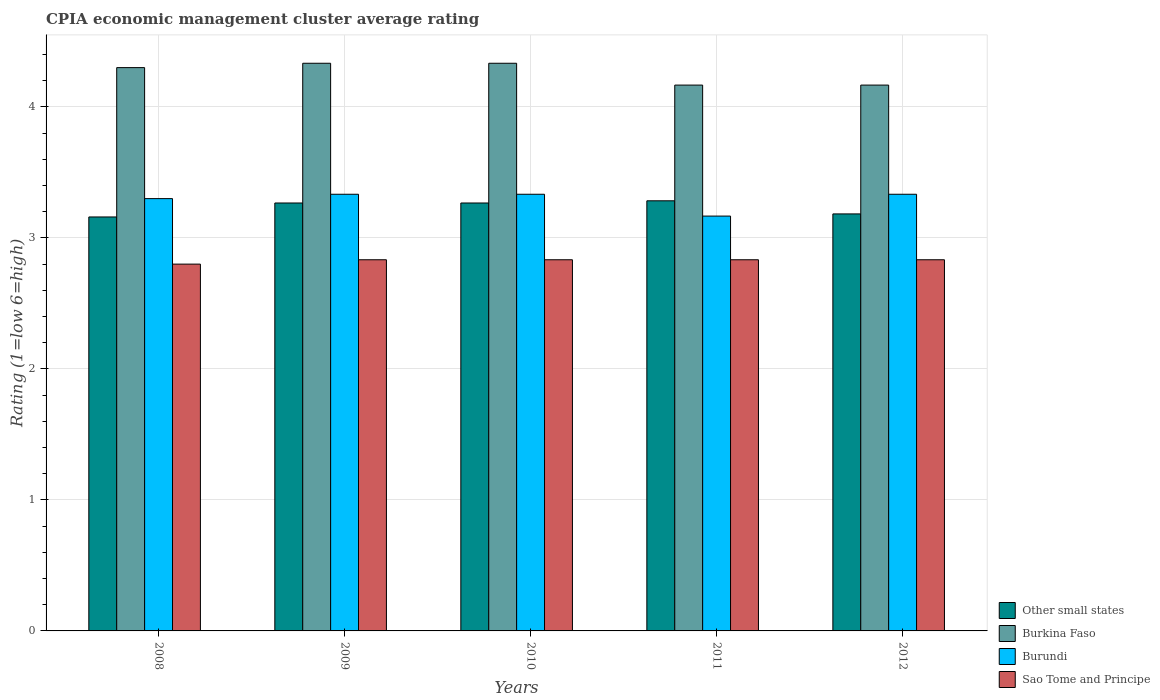Are the number of bars per tick equal to the number of legend labels?
Your response must be concise. Yes. What is the CPIA rating in Other small states in 2010?
Provide a short and direct response. 3.27. Across all years, what is the maximum CPIA rating in Burkina Faso?
Provide a short and direct response. 4.33. Across all years, what is the minimum CPIA rating in Sao Tome and Principe?
Your answer should be compact. 2.8. In which year was the CPIA rating in Burkina Faso minimum?
Provide a succinct answer. 2011. What is the total CPIA rating in Other small states in the graph?
Ensure brevity in your answer.  16.16. What is the difference between the CPIA rating in Other small states in 2010 and that in 2011?
Provide a succinct answer. -0.02. What is the difference between the CPIA rating in Sao Tome and Principe in 2011 and the CPIA rating in Burkina Faso in 2008?
Offer a terse response. -1.47. What is the average CPIA rating in Sao Tome and Principe per year?
Keep it short and to the point. 2.83. What is the ratio of the CPIA rating in Other small states in 2011 to that in 2012?
Offer a terse response. 1.03. What is the difference between the highest and the second highest CPIA rating in Burkina Faso?
Provide a succinct answer. 0. What is the difference between the highest and the lowest CPIA rating in Other small states?
Your answer should be compact. 0.12. In how many years, is the CPIA rating in Sao Tome and Principe greater than the average CPIA rating in Sao Tome and Principe taken over all years?
Give a very brief answer. 4. Is the sum of the CPIA rating in Burundi in 2008 and 2012 greater than the maximum CPIA rating in Burkina Faso across all years?
Your response must be concise. Yes. Is it the case that in every year, the sum of the CPIA rating in Burkina Faso and CPIA rating in Sao Tome and Principe is greater than the sum of CPIA rating in Burundi and CPIA rating in Other small states?
Provide a succinct answer. Yes. What does the 1st bar from the left in 2008 represents?
Ensure brevity in your answer.  Other small states. What does the 4th bar from the right in 2010 represents?
Keep it short and to the point. Other small states. Are all the bars in the graph horizontal?
Offer a terse response. No. How many years are there in the graph?
Provide a succinct answer. 5. Does the graph contain any zero values?
Your answer should be very brief. No. Does the graph contain grids?
Offer a very short reply. Yes. Where does the legend appear in the graph?
Your answer should be very brief. Bottom right. How many legend labels are there?
Offer a terse response. 4. What is the title of the graph?
Make the answer very short. CPIA economic management cluster average rating. What is the label or title of the Y-axis?
Provide a short and direct response. Rating (1=low 6=high). What is the Rating (1=low 6=high) in Other small states in 2008?
Offer a very short reply. 3.16. What is the Rating (1=low 6=high) of Burundi in 2008?
Your answer should be very brief. 3.3. What is the Rating (1=low 6=high) of Sao Tome and Principe in 2008?
Offer a very short reply. 2.8. What is the Rating (1=low 6=high) in Other small states in 2009?
Your answer should be compact. 3.27. What is the Rating (1=low 6=high) of Burkina Faso in 2009?
Ensure brevity in your answer.  4.33. What is the Rating (1=low 6=high) of Burundi in 2009?
Provide a succinct answer. 3.33. What is the Rating (1=low 6=high) in Sao Tome and Principe in 2009?
Offer a terse response. 2.83. What is the Rating (1=low 6=high) in Other small states in 2010?
Keep it short and to the point. 3.27. What is the Rating (1=low 6=high) in Burkina Faso in 2010?
Provide a succinct answer. 4.33. What is the Rating (1=low 6=high) of Burundi in 2010?
Provide a short and direct response. 3.33. What is the Rating (1=low 6=high) in Sao Tome and Principe in 2010?
Make the answer very short. 2.83. What is the Rating (1=low 6=high) in Other small states in 2011?
Your answer should be very brief. 3.28. What is the Rating (1=low 6=high) in Burkina Faso in 2011?
Provide a short and direct response. 4.17. What is the Rating (1=low 6=high) of Burundi in 2011?
Provide a succinct answer. 3.17. What is the Rating (1=low 6=high) of Sao Tome and Principe in 2011?
Your answer should be compact. 2.83. What is the Rating (1=low 6=high) of Other small states in 2012?
Provide a succinct answer. 3.18. What is the Rating (1=low 6=high) in Burkina Faso in 2012?
Provide a succinct answer. 4.17. What is the Rating (1=low 6=high) in Burundi in 2012?
Offer a terse response. 3.33. What is the Rating (1=low 6=high) of Sao Tome and Principe in 2012?
Your answer should be compact. 2.83. Across all years, what is the maximum Rating (1=low 6=high) in Other small states?
Offer a very short reply. 3.28. Across all years, what is the maximum Rating (1=low 6=high) in Burkina Faso?
Offer a very short reply. 4.33. Across all years, what is the maximum Rating (1=low 6=high) in Burundi?
Provide a short and direct response. 3.33. Across all years, what is the maximum Rating (1=low 6=high) in Sao Tome and Principe?
Your answer should be compact. 2.83. Across all years, what is the minimum Rating (1=low 6=high) of Other small states?
Your response must be concise. 3.16. Across all years, what is the minimum Rating (1=low 6=high) in Burkina Faso?
Make the answer very short. 4.17. Across all years, what is the minimum Rating (1=low 6=high) in Burundi?
Offer a very short reply. 3.17. Across all years, what is the minimum Rating (1=low 6=high) of Sao Tome and Principe?
Provide a succinct answer. 2.8. What is the total Rating (1=low 6=high) of Other small states in the graph?
Your answer should be compact. 16.16. What is the total Rating (1=low 6=high) of Burkina Faso in the graph?
Provide a short and direct response. 21.3. What is the total Rating (1=low 6=high) of Burundi in the graph?
Provide a succinct answer. 16.47. What is the total Rating (1=low 6=high) of Sao Tome and Principe in the graph?
Offer a very short reply. 14.13. What is the difference between the Rating (1=low 6=high) in Other small states in 2008 and that in 2009?
Offer a terse response. -0.11. What is the difference between the Rating (1=low 6=high) in Burkina Faso in 2008 and that in 2009?
Provide a short and direct response. -0.03. What is the difference between the Rating (1=low 6=high) of Burundi in 2008 and that in 2009?
Offer a terse response. -0.03. What is the difference between the Rating (1=low 6=high) of Sao Tome and Principe in 2008 and that in 2009?
Your answer should be compact. -0.03. What is the difference between the Rating (1=low 6=high) in Other small states in 2008 and that in 2010?
Provide a succinct answer. -0.11. What is the difference between the Rating (1=low 6=high) in Burkina Faso in 2008 and that in 2010?
Ensure brevity in your answer.  -0.03. What is the difference between the Rating (1=low 6=high) in Burundi in 2008 and that in 2010?
Your answer should be compact. -0.03. What is the difference between the Rating (1=low 6=high) of Sao Tome and Principe in 2008 and that in 2010?
Your answer should be compact. -0.03. What is the difference between the Rating (1=low 6=high) of Other small states in 2008 and that in 2011?
Provide a succinct answer. -0.12. What is the difference between the Rating (1=low 6=high) of Burkina Faso in 2008 and that in 2011?
Provide a short and direct response. 0.13. What is the difference between the Rating (1=low 6=high) in Burundi in 2008 and that in 2011?
Your answer should be very brief. 0.13. What is the difference between the Rating (1=low 6=high) of Sao Tome and Principe in 2008 and that in 2011?
Provide a succinct answer. -0.03. What is the difference between the Rating (1=low 6=high) in Other small states in 2008 and that in 2012?
Your answer should be very brief. -0.02. What is the difference between the Rating (1=low 6=high) in Burkina Faso in 2008 and that in 2012?
Your answer should be compact. 0.13. What is the difference between the Rating (1=low 6=high) of Burundi in 2008 and that in 2012?
Give a very brief answer. -0.03. What is the difference between the Rating (1=low 6=high) in Sao Tome and Principe in 2008 and that in 2012?
Give a very brief answer. -0.03. What is the difference between the Rating (1=low 6=high) in Burundi in 2009 and that in 2010?
Offer a very short reply. 0. What is the difference between the Rating (1=low 6=high) in Other small states in 2009 and that in 2011?
Your response must be concise. -0.02. What is the difference between the Rating (1=low 6=high) in Burkina Faso in 2009 and that in 2011?
Your answer should be very brief. 0.17. What is the difference between the Rating (1=low 6=high) in Sao Tome and Principe in 2009 and that in 2011?
Keep it short and to the point. 0. What is the difference between the Rating (1=low 6=high) in Other small states in 2009 and that in 2012?
Ensure brevity in your answer.  0.08. What is the difference between the Rating (1=low 6=high) in Burkina Faso in 2009 and that in 2012?
Offer a very short reply. 0.17. What is the difference between the Rating (1=low 6=high) of Burundi in 2009 and that in 2012?
Give a very brief answer. 0. What is the difference between the Rating (1=low 6=high) in Sao Tome and Principe in 2009 and that in 2012?
Provide a succinct answer. 0. What is the difference between the Rating (1=low 6=high) of Other small states in 2010 and that in 2011?
Your answer should be very brief. -0.02. What is the difference between the Rating (1=low 6=high) of Burkina Faso in 2010 and that in 2011?
Keep it short and to the point. 0.17. What is the difference between the Rating (1=low 6=high) in Sao Tome and Principe in 2010 and that in 2011?
Offer a very short reply. 0. What is the difference between the Rating (1=low 6=high) of Other small states in 2010 and that in 2012?
Make the answer very short. 0.08. What is the difference between the Rating (1=low 6=high) in Burkina Faso in 2010 and that in 2012?
Provide a succinct answer. 0.17. What is the difference between the Rating (1=low 6=high) in Sao Tome and Principe in 2010 and that in 2012?
Offer a terse response. 0. What is the difference between the Rating (1=low 6=high) in Burundi in 2011 and that in 2012?
Ensure brevity in your answer.  -0.17. What is the difference between the Rating (1=low 6=high) of Other small states in 2008 and the Rating (1=low 6=high) of Burkina Faso in 2009?
Offer a terse response. -1.17. What is the difference between the Rating (1=low 6=high) in Other small states in 2008 and the Rating (1=low 6=high) in Burundi in 2009?
Make the answer very short. -0.17. What is the difference between the Rating (1=low 6=high) of Other small states in 2008 and the Rating (1=low 6=high) of Sao Tome and Principe in 2009?
Offer a very short reply. 0.33. What is the difference between the Rating (1=low 6=high) of Burkina Faso in 2008 and the Rating (1=low 6=high) of Burundi in 2009?
Your response must be concise. 0.97. What is the difference between the Rating (1=low 6=high) of Burkina Faso in 2008 and the Rating (1=low 6=high) of Sao Tome and Principe in 2009?
Keep it short and to the point. 1.47. What is the difference between the Rating (1=low 6=high) of Burundi in 2008 and the Rating (1=low 6=high) of Sao Tome and Principe in 2009?
Provide a succinct answer. 0.47. What is the difference between the Rating (1=low 6=high) in Other small states in 2008 and the Rating (1=low 6=high) in Burkina Faso in 2010?
Provide a short and direct response. -1.17. What is the difference between the Rating (1=low 6=high) in Other small states in 2008 and the Rating (1=low 6=high) in Burundi in 2010?
Provide a short and direct response. -0.17. What is the difference between the Rating (1=low 6=high) of Other small states in 2008 and the Rating (1=low 6=high) of Sao Tome and Principe in 2010?
Provide a succinct answer. 0.33. What is the difference between the Rating (1=low 6=high) of Burkina Faso in 2008 and the Rating (1=low 6=high) of Burundi in 2010?
Make the answer very short. 0.97. What is the difference between the Rating (1=low 6=high) of Burkina Faso in 2008 and the Rating (1=low 6=high) of Sao Tome and Principe in 2010?
Offer a very short reply. 1.47. What is the difference between the Rating (1=low 6=high) of Burundi in 2008 and the Rating (1=low 6=high) of Sao Tome and Principe in 2010?
Make the answer very short. 0.47. What is the difference between the Rating (1=low 6=high) in Other small states in 2008 and the Rating (1=low 6=high) in Burkina Faso in 2011?
Your answer should be compact. -1.01. What is the difference between the Rating (1=low 6=high) of Other small states in 2008 and the Rating (1=low 6=high) of Burundi in 2011?
Your response must be concise. -0.01. What is the difference between the Rating (1=low 6=high) of Other small states in 2008 and the Rating (1=low 6=high) of Sao Tome and Principe in 2011?
Give a very brief answer. 0.33. What is the difference between the Rating (1=low 6=high) of Burkina Faso in 2008 and the Rating (1=low 6=high) of Burundi in 2011?
Make the answer very short. 1.13. What is the difference between the Rating (1=low 6=high) in Burkina Faso in 2008 and the Rating (1=low 6=high) in Sao Tome and Principe in 2011?
Make the answer very short. 1.47. What is the difference between the Rating (1=low 6=high) in Burundi in 2008 and the Rating (1=low 6=high) in Sao Tome and Principe in 2011?
Provide a short and direct response. 0.47. What is the difference between the Rating (1=low 6=high) of Other small states in 2008 and the Rating (1=low 6=high) of Burkina Faso in 2012?
Your answer should be very brief. -1.01. What is the difference between the Rating (1=low 6=high) in Other small states in 2008 and the Rating (1=low 6=high) in Burundi in 2012?
Make the answer very short. -0.17. What is the difference between the Rating (1=low 6=high) of Other small states in 2008 and the Rating (1=low 6=high) of Sao Tome and Principe in 2012?
Provide a succinct answer. 0.33. What is the difference between the Rating (1=low 6=high) of Burkina Faso in 2008 and the Rating (1=low 6=high) of Burundi in 2012?
Offer a terse response. 0.97. What is the difference between the Rating (1=low 6=high) in Burkina Faso in 2008 and the Rating (1=low 6=high) in Sao Tome and Principe in 2012?
Ensure brevity in your answer.  1.47. What is the difference between the Rating (1=low 6=high) in Burundi in 2008 and the Rating (1=low 6=high) in Sao Tome and Principe in 2012?
Provide a succinct answer. 0.47. What is the difference between the Rating (1=low 6=high) in Other small states in 2009 and the Rating (1=low 6=high) in Burkina Faso in 2010?
Your answer should be very brief. -1.07. What is the difference between the Rating (1=low 6=high) in Other small states in 2009 and the Rating (1=low 6=high) in Burundi in 2010?
Make the answer very short. -0.07. What is the difference between the Rating (1=low 6=high) in Other small states in 2009 and the Rating (1=low 6=high) in Sao Tome and Principe in 2010?
Provide a short and direct response. 0.43. What is the difference between the Rating (1=low 6=high) of Burkina Faso in 2009 and the Rating (1=low 6=high) of Sao Tome and Principe in 2010?
Provide a short and direct response. 1.5. What is the difference between the Rating (1=low 6=high) in Burundi in 2009 and the Rating (1=low 6=high) in Sao Tome and Principe in 2010?
Provide a short and direct response. 0.5. What is the difference between the Rating (1=low 6=high) in Other small states in 2009 and the Rating (1=low 6=high) in Burkina Faso in 2011?
Offer a terse response. -0.9. What is the difference between the Rating (1=low 6=high) in Other small states in 2009 and the Rating (1=low 6=high) in Sao Tome and Principe in 2011?
Give a very brief answer. 0.43. What is the difference between the Rating (1=low 6=high) of Burkina Faso in 2009 and the Rating (1=low 6=high) of Burundi in 2011?
Offer a terse response. 1.17. What is the difference between the Rating (1=low 6=high) in Burkina Faso in 2009 and the Rating (1=low 6=high) in Sao Tome and Principe in 2011?
Keep it short and to the point. 1.5. What is the difference between the Rating (1=low 6=high) of Other small states in 2009 and the Rating (1=low 6=high) of Burkina Faso in 2012?
Offer a very short reply. -0.9. What is the difference between the Rating (1=low 6=high) of Other small states in 2009 and the Rating (1=low 6=high) of Burundi in 2012?
Give a very brief answer. -0.07. What is the difference between the Rating (1=low 6=high) of Other small states in 2009 and the Rating (1=low 6=high) of Sao Tome and Principe in 2012?
Offer a terse response. 0.43. What is the difference between the Rating (1=low 6=high) of Burkina Faso in 2009 and the Rating (1=low 6=high) of Burundi in 2012?
Ensure brevity in your answer.  1. What is the difference between the Rating (1=low 6=high) in Burkina Faso in 2009 and the Rating (1=low 6=high) in Sao Tome and Principe in 2012?
Your answer should be very brief. 1.5. What is the difference between the Rating (1=low 6=high) of Burundi in 2009 and the Rating (1=low 6=high) of Sao Tome and Principe in 2012?
Your answer should be compact. 0.5. What is the difference between the Rating (1=low 6=high) of Other small states in 2010 and the Rating (1=low 6=high) of Burkina Faso in 2011?
Offer a very short reply. -0.9. What is the difference between the Rating (1=low 6=high) of Other small states in 2010 and the Rating (1=low 6=high) of Burundi in 2011?
Offer a terse response. 0.1. What is the difference between the Rating (1=low 6=high) of Other small states in 2010 and the Rating (1=low 6=high) of Sao Tome and Principe in 2011?
Ensure brevity in your answer.  0.43. What is the difference between the Rating (1=low 6=high) of Burkina Faso in 2010 and the Rating (1=low 6=high) of Sao Tome and Principe in 2011?
Your response must be concise. 1.5. What is the difference between the Rating (1=low 6=high) in Burundi in 2010 and the Rating (1=low 6=high) in Sao Tome and Principe in 2011?
Your answer should be very brief. 0.5. What is the difference between the Rating (1=low 6=high) in Other small states in 2010 and the Rating (1=low 6=high) in Burundi in 2012?
Offer a very short reply. -0.07. What is the difference between the Rating (1=low 6=high) in Other small states in 2010 and the Rating (1=low 6=high) in Sao Tome and Principe in 2012?
Give a very brief answer. 0.43. What is the difference between the Rating (1=low 6=high) of Burkina Faso in 2010 and the Rating (1=low 6=high) of Burundi in 2012?
Make the answer very short. 1. What is the difference between the Rating (1=low 6=high) in Burkina Faso in 2010 and the Rating (1=low 6=high) in Sao Tome and Principe in 2012?
Your answer should be very brief. 1.5. What is the difference between the Rating (1=low 6=high) in Burundi in 2010 and the Rating (1=low 6=high) in Sao Tome and Principe in 2012?
Provide a succinct answer. 0.5. What is the difference between the Rating (1=low 6=high) in Other small states in 2011 and the Rating (1=low 6=high) in Burkina Faso in 2012?
Give a very brief answer. -0.88. What is the difference between the Rating (1=low 6=high) of Other small states in 2011 and the Rating (1=low 6=high) of Sao Tome and Principe in 2012?
Provide a succinct answer. 0.45. What is the difference between the Rating (1=low 6=high) of Burkina Faso in 2011 and the Rating (1=low 6=high) of Sao Tome and Principe in 2012?
Provide a short and direct response. 1.33. What is the difference between the Rating (1=low 6=high) in Burundi in 2011 and the Rating (1=low 6=high) in Sao Tome and Principe in 2012?
Offer a very short reply. 0.33. What is the average Rating (1=low 6=high) in Other small states per year?
Make the answer very short. 3.23. What is the average Rating (1=low 6=high) of Burkina Faso per year?
Provide a short and direct response. 4.26. What is the average Rating (1=low 6=high) of Burundi per year?
Provide a succinct answer. 3.29. What is the average Rating (1=low 6=high) of Sao Tome and Principe per year?
Your answer should be compact. 2.83. In the year 2008, what is the difference between the Rating (1=low 6=high) of Other small states and Rating (1=low 6=high) of Burkina Faso?
Ensure brevity in your answer.  -1.14. In the year 2008, what is the difference between the Rating (1=low 6=high) in Other small states and Rating (1=low 6=high) in Burundi?
Ensure brevity in your answer.  -0.14. In the year 2008, what is the difference between the Rating (1=low 6=high) of Other small states and Rating (1=low 6=high) of Sao Tome and Principe?
Ensure brevity in your answer.  0.36. In the year 2009, what is the difference between the Rating (1=low 6=high) of Other small states and Rating (1=low 6=high) of Burkina Faso?
Offer a very short reply. -1.07. In the year 2009, what is the difference between the Rating (1=low 6=high) in Other small states and Rating (1=low 6=high) in Burundi?
Give a very brief answer. -0.07. In the year 2009, what is the difference between the Rating (1=low 6=high) of Other small states and Rating (1=low 6=high) of Sao Tome and Principe?
Offer a very short reply. 0.43. In the year 2009, what is the difference between the Rating (1=low 6=high) in Burkina Faso and Rating (1=low 6=high) in Burundi?
Offer a terse response. 1. In the year 2010, what is the difference between the Rating (1=low 6=high) of Other small states and Rating (1=low 6=high) of Burkina Faso?
Provide a short and direct response. -1.07. In the year 2010, what is the difference between the Rating (1=low 6=high) in Other small states and Rating (1=low 6=high) in Burundi?
Provide a short and direct response. -0.07. In the year 2010, what is the difference between the Rating (1=low 6=high) of Other small states and Rating (1=low 6=high) of Sao Tome and Principe?
Give a very brief answer. 0.43. In the year 2010, what is the difference between the Rating (1=low 6=high) of Burkina Faso and Rating (1=low 6=high) of Burundi?
Give a very brief answer. 1. In the year 2011, what is the difference between the Rating (1=low 6=high) in Other small states and Rating (1=low 6=high) in Burkina Faso?
Ensure brevity in your answer.  -0.88. In the year 2011, what is the difference between the Rating (1=low 6=high) of Other small states and Rating (1=low 6=high) of Burundi?
Offer a very short reply. 0.12. In the year 2011, what is the difference between the Rating (1=low 6=high) in Other small states and Rating (1=low 6=high) in Sao Tome and Principe?
Ensure brevity in your answer.  0.45. In the year 2011, what is the difference between the Rating (1=low 6=high) of Burkina Faso and Rating (1=low 6=high) of Sao Tome and Principe?
Your answer should be compact. 1.33. In the year 2012, what is the difference between the Rating (1=low 6=high) in Other small states and Rating (1=low 6=high) in Burkina Faso?
Your answer should be compact. -0.98. In the year 2012, what is the difference between the Rating (1=low 6=high) in Other small states and Rating (1=low 6=high) in Burundi?
Offer a terse response. -0.15. In the year 2012, what is the difference between the Rating (1=low 6=high) of Burkina Faso and Rating (1=low 6=high) of Sao Tome and Principe?
Your answer should be very brief. 1.33. In the year 2012, what is the difference between the Rating (1=low 6=high) of Burundi and Rating (1=low 6=high) of Sao Tome and Principe?
Ensure brevity in your answer.  0.5. What is the ratio of the Rating (1=low 6=high) in Other small states in 2008 to that in 2009?
Ensure brevity in your answer.  0.97. What is the ratio of the Rating (1=low 6=high) in Burundi in 2008 to that in 2009?
Your response must be concise. 0.99. What is the ratio of the Rating (1=low 6=high) in Sao Tome and Principe in 2008 to that in 2009?
Ensure brevity in your answer.  0.99. What is the ratio of the Rating (1=low 6=high) of Other small states in 2008 to that in 2010?
Your answer should be compact. 0.97. What is the ratio of the Rating (1=low 6=high) in Sao Tome and Principe in 2008 to that in 2010?
Offer a terse response. 0.99. What is the ratio of the Rating (1=low 6=high) of Other small states in 2008 to that in 2011?
Your response must be concise. 0.96. What is the ratio of the Rating (1=low 6=high) in Burkina Faso in 2008 to that in 2011?
Ensure brevity in your answer.  1.03. What is the ratio of the Rating (1=low 6=high) in Burundi in 2008 to that in 2011?
Give a very brief answer. 1.04. What is the ratio of the Rating (1=low 6=high) of Burkina Faso in 2008 to that in 2012?
Give a very brief answer. 1.03. What is the ratio of the Rating (1=low 6=high) of Sao Tome and Principe in 2008 to that in 2012?
Make the answer very short. 0.99. What is the ratio of the Rating (1=low 6=high) of Other small states in 2009 to that in 2010?
Your response must be concise. 1. What is the ratio of the Rating (1=low 6=high) of Other small states in 2009 to that in 2011?
Your response must be concise. 0.99. What is the ratio of the Rating (1=low 6=high) of Burkina Faso in 2009 to that in 2011?
Offer a very short reply. 1.04. What is the ratio of the Rating (1=low 6=high) in Burundi in 2009 to that in 2011?
Offer a very short reply. 1.05. What is the ratio of the Rating (1=low 6=high) in Sao Tome and Principe in 2009 to that in 2011?
Offer a terse response. 1. What is the ratio of the Rating (1=low 6=high) of Other small states in 2009 to that in 2012?
Make the answer very short. 1.03. What is the ratio of the Rating (1=low 6=high) in Sao Tome and Principe in 2009 to that in 2012?
Offer a very short reply. 1. What is the ratio of the Rating (1=low 6=high) of Burundi in 2010 to that in 2011?
Ensure brevity in your answer.  1.05. What is the ratio of the Rating (1=low 6=high) of Other small states in 2010 to that in 2012?
Keep it short and to the point. 1.03. What is the ratio of the Rating (1=low 6=high) of Other small states in 2011 to that in 2012?
Offer a very short reply. 1.03. What is the ratio of the Rating (1=low 6=high) of Sao Tome and Principe in 2011 to that in 2012?
Your answer should be compact. 1. What is the difference between the highest and the second highest Rating (1=low 6=high) of Other small states?
Offer a very short reply. 0.02. What is the difference between the highest and the second highest Rating (1=low 6=high) in Burundi?
Keep it short and to the point. 0. What is the difference between the highest and the lowest Rating (1=low 6=high) in Other small states?
Your response must be concise. 0.12. What is the difference between the highest and the lowest Rating (1=low 6=high) of Burundi?
Provide a succinct answer. 0.17. 